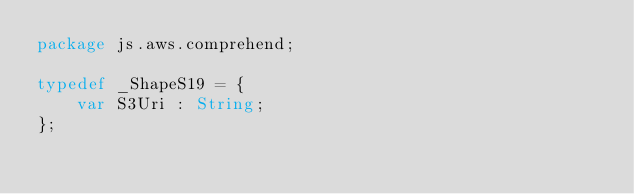<code> <loc_0><loc_0><loc_500><loc_500><_Haxe_>package js.aws.comprehend;

typedef _ShapeS19 = {
    var S3Uri : String;
};
</code> 